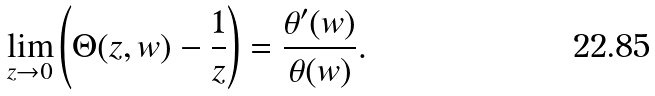Convert formula to latex. <formula><loc_0><loc_0><loc_500><loc_500>\lim _ { z \rightarrow 0 } \left ( \Theta ( z , w ) - \frac { 1 } { z } \right ) = \frac { \theta ^ { \prime } ( w ) } { \theta ( w ) } .</formula> 